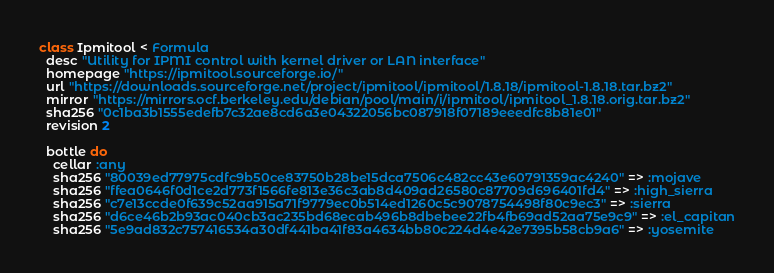<code> <loc_0><loc_0><loc_500><loc_500><_Ruby_>class Ipmitool < Formula
  desc "Utility for IPMI control with kernel driver or LAN interface"
  homepage "https://ipmitool.sourceforge.io/"
  url "https://downloads.sourceforge.net/project/ipmitool/ipmitool/1.8.18/ipmitool-1.8.18.tar.bz2"
  mirror "https://mirrors.ocf.berkeley.edu/debian/pool/main/i/ipmitool/ipmitool_1.8.18.orig.tar.bz2"
  sha256 "0c1ba3b1555edefb7c32ae8cd6a3e04322056bc087918f07189eeedfc8b81e01"
  revision 2

  bottle do
    cellar :any
    sha256 "80039ed77975cdfc9b50ce83750b28be15dca7506c482cc43e60791359ac4240" => :mojave
    sha256 "ffea0646f0d1ce2d773f1566fe813e36c3ab8d409ad26580c87709d696401fd4" => :high_sierra
    sha256 "c7e13ccde0f639c52aa915a71f9779ec0b514ed1260c5c9078754498f80c9ec3" => :sierra
    sha256 "d6ce46b2b93ac040cb3ac235bd68ecab496b8dbebee22fb4fb69ad52aa75e9c9" => :el_capitan
    sha256 "5e9ad832c757416534a30df441ba41f83a4634bb80c224d4e42e7395b58cb9a6" => :yosemite</code> 